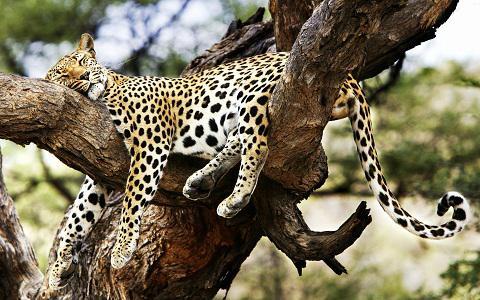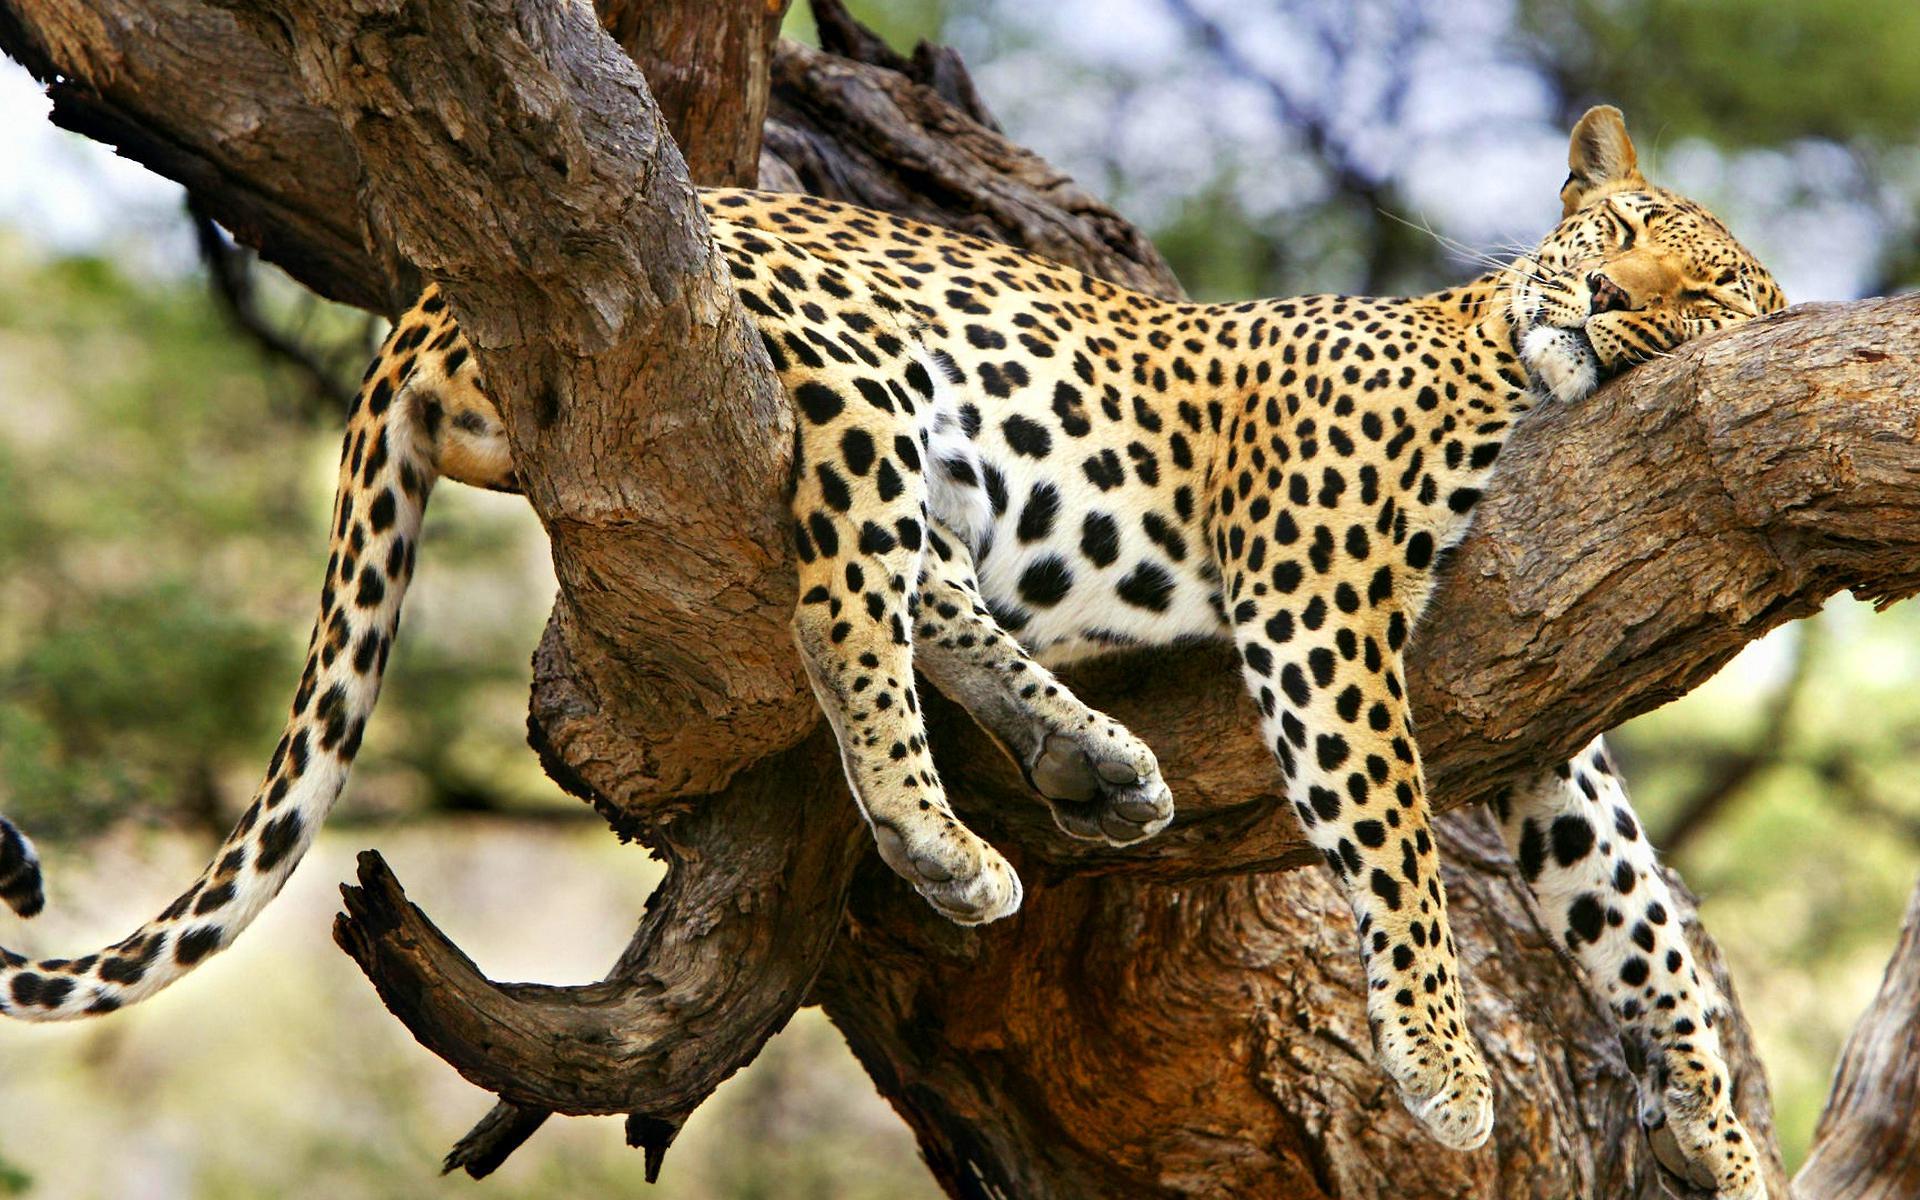The first image is the image on the left, the second image is the image on the right. Evaluate the accuracy of this statement regarding the images: "At least one animal is sleeping in a tree.". Is it true? Answer yes or no. Yes. 